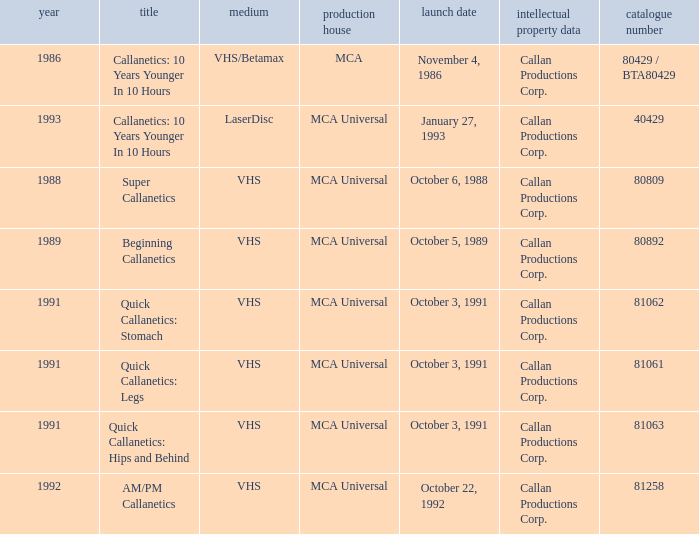Name the catalog number for  october 6, 1988 80809.0. 